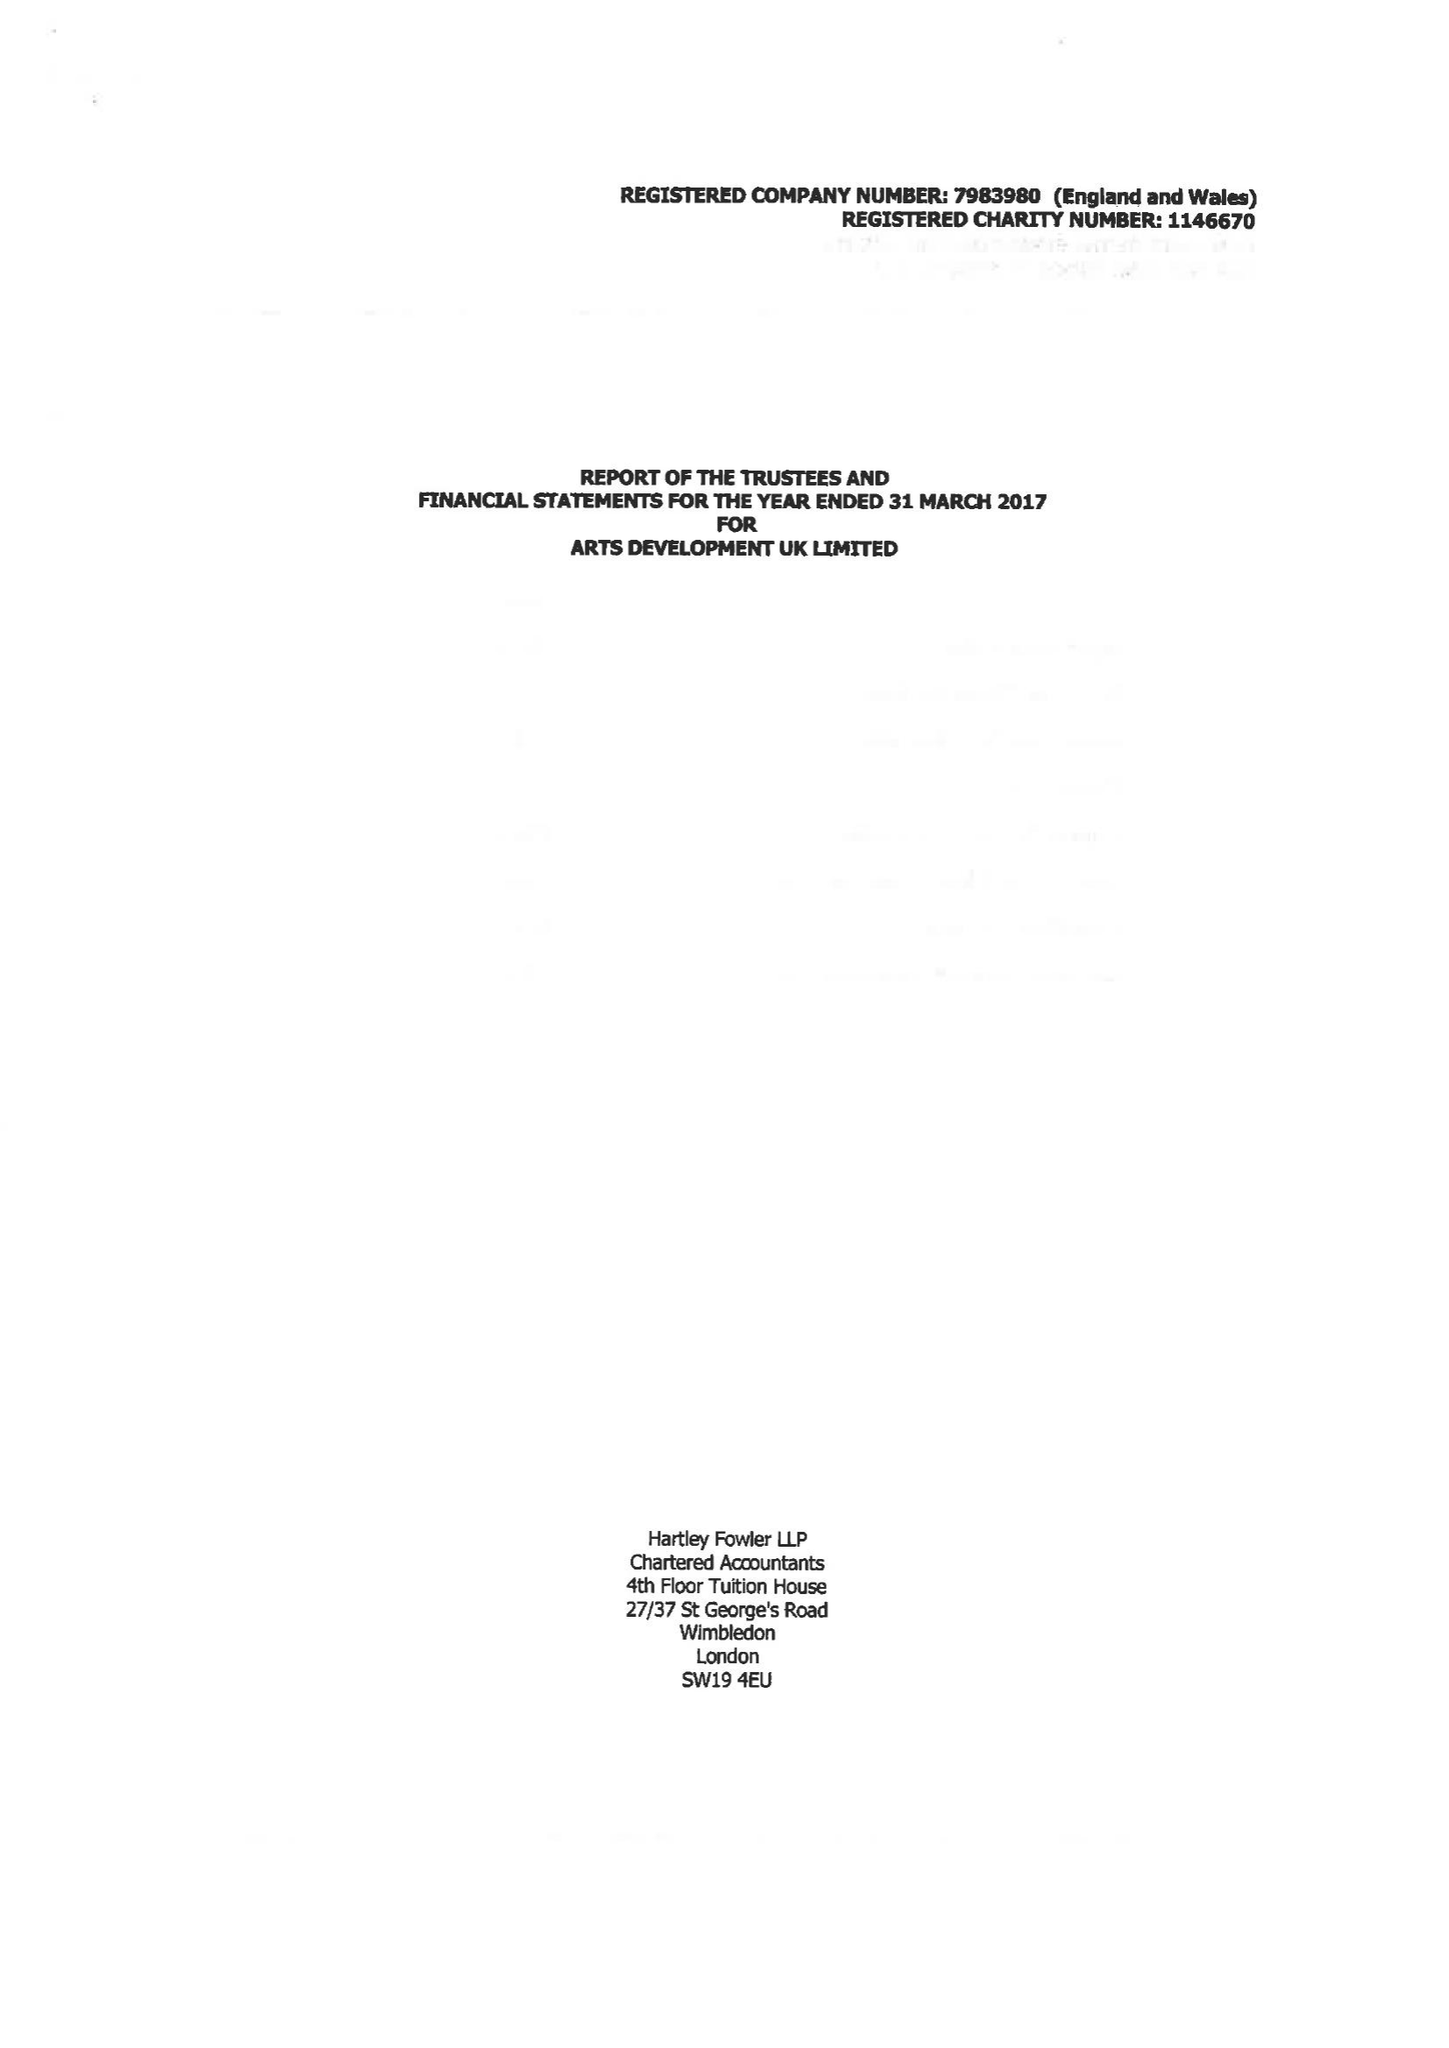What is the value for the spending_annually_in_british_pounds?
Answer the question using a single word or phrase. 185238.00 